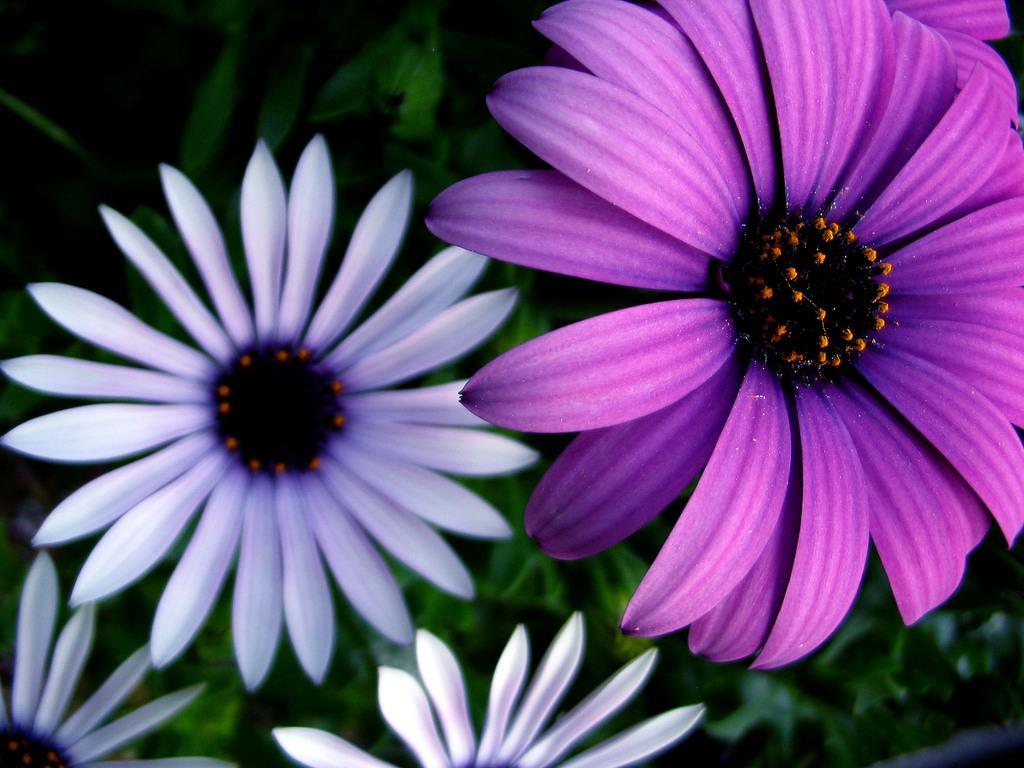Can you describe this image briefly? In this picture, we see flowers and these flowers are in white and purple color. In the background, we see the plants or the trees. This picture is blurred in the background. 